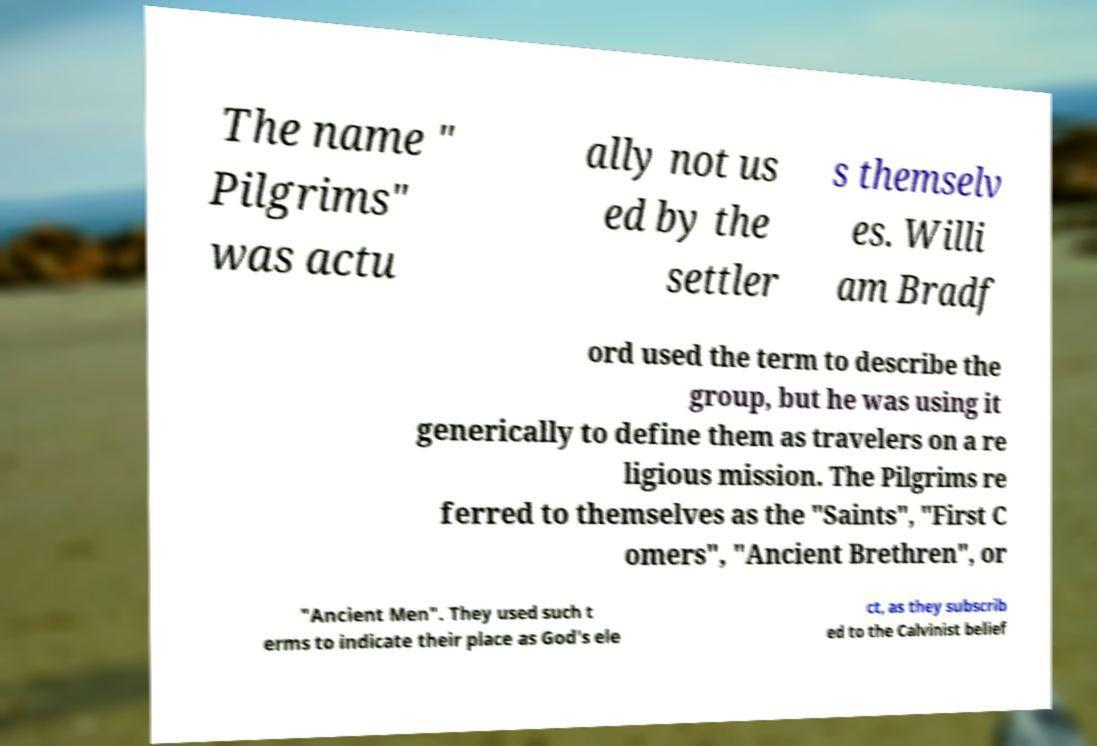There's text embedded in this image that I need extracted. Can you transcribe it verbatim? The name " Pilgrims" was actu ally not us ed by the settler s themselv es. Willi am Bradf ord used the term to describe the group, but he was using it generically to define them as travelers on a re ligious mission. The Pilgrims re ferred to themselves as the "Saints", "First C omers", "Ancient Brethren", or "Ancient Men". They used such t erms to indicate their place as God's ele ct, as they subscrib ed to the Calvinist belief 